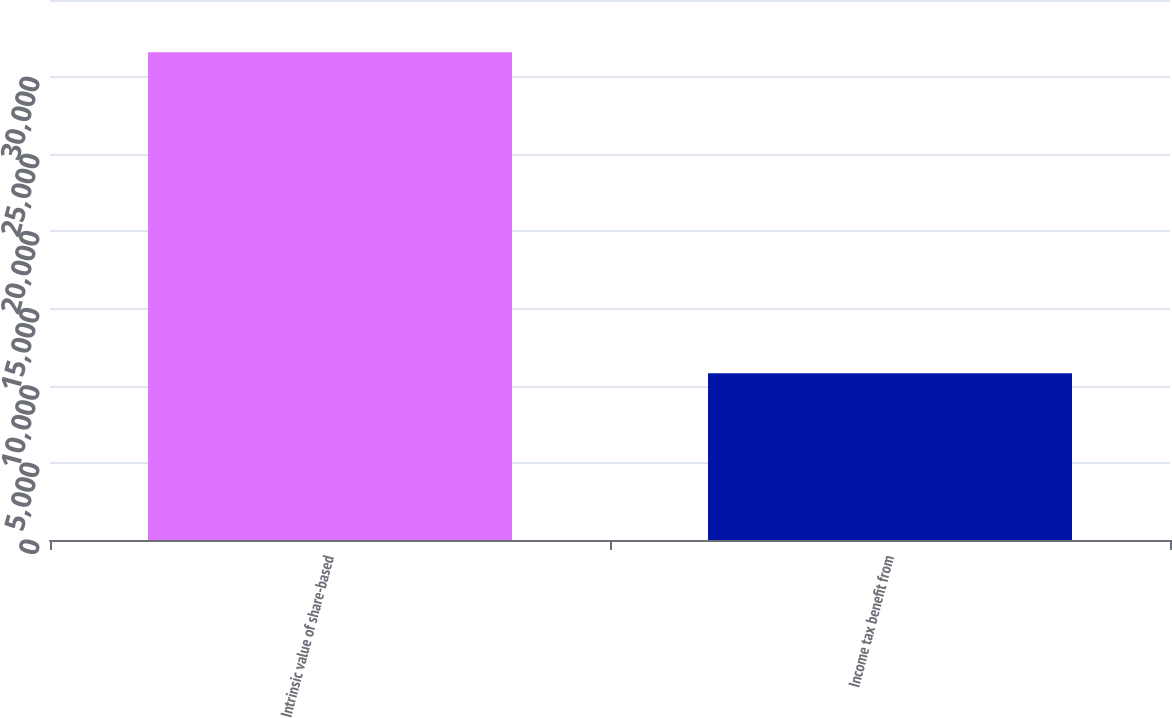<chart> <loc_0><loc_0><loc_500><loc_500><bar_chart><fcel>Intrinsic value of share-based<fcel>Income tax benefit from<nl><fcel>31613<fcel>10805<nl></chart> 